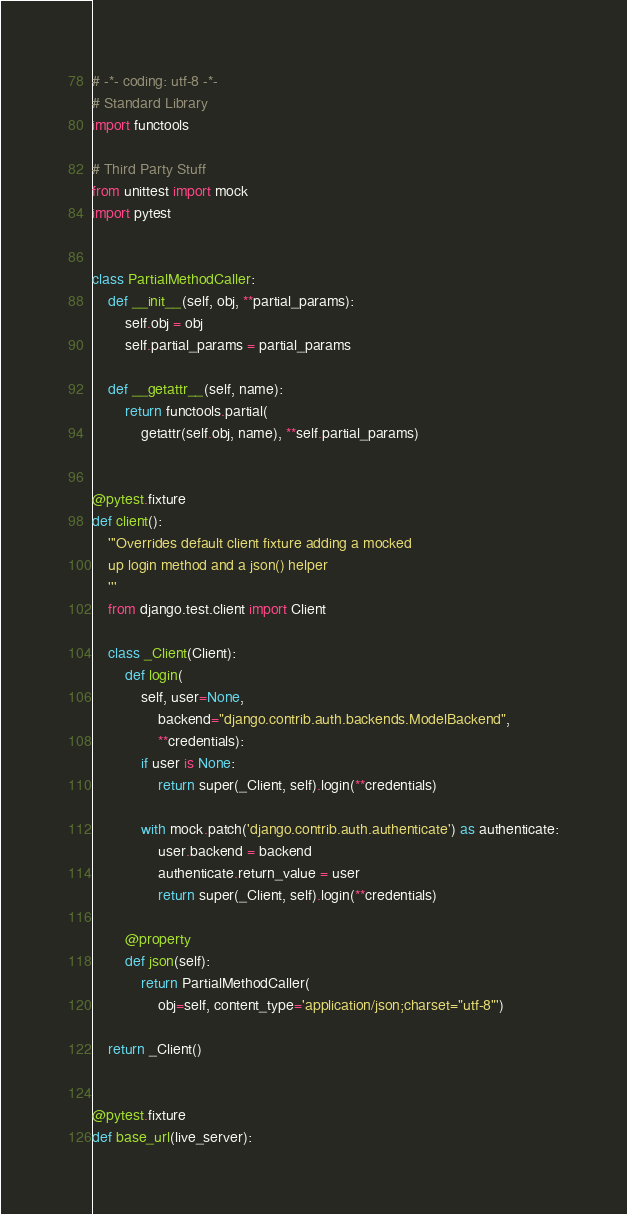<code> <loc_0><loc_0><loc_500><loc_500><_Python_># -*- coding: utf-8 -*-
# Standard Library
import functools

# Third Party Stuff
from unittest import mock
import pytest


class PartialMethodCaller:
    def __init__(self, obj, **partial_params):
        self.obj = obj
        self.partial_params = partial_params

    def __getattr__(self, name):
        return functools.partial(
            getattr(self.obj, name), **self.partial_params)


@pytest.fixture
def client():
    '''Overrides default client fixture adding a mocked
    up login method and a json() helper
    '''
    from django.test.client import Client

    class _Client(Client):
        def login(
            self, user=None,
                backend="django.contrib.auth.backends.ModelBackend",
                **credentials):
            if user is None:
                return super(_Client, self).login(**credentials)

            with mock.patch('django.contrib.auth.authenticate') as authenticate:
                user.backend = backend
                authenticate.return_value = user
                return super(_Client, self).login(**credentials)

        @property
        def json(self):
            return PartialMethodCaller(
                obj=self, content_type='application/json;charset="utf-8"')

    return _Client()


@pytest.fixture
def base_url(live_server):</code> 